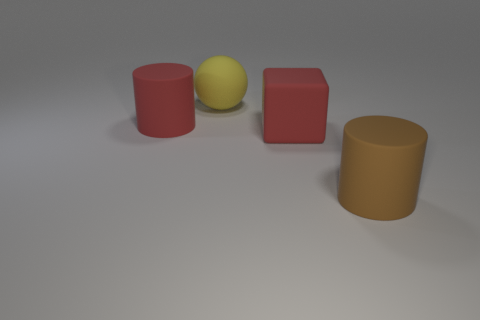There is a red block that is made of the same material as the large brown cylinder; what size is it?
Offer a terse response. Large. Is the shape of the thing that is on the left side of the sphere the same as the large red rubber object that is to the right of the yellow matte sphere?
Provide a succinct answer. No. What is the color of the big cube that is made of the same material as the ball?
Your answer should be compact. Red. What is the shape of the large thing that is both in front of the yellow matte object and behind the large rubber block?
Keep it short and to the point. Cylinder. Are there any tiny gray spheres made of the same material as the brown object?
Your answer should be very brief. No. What is the material of the large thing that is the same color as the large matte block?
Your answer should be very brief. Rubber. Is the material of the big red object in front of the big red cylinder the same as the big cylinder on the right side of the sphere?
Offer a very short reply. Yes. Are there more small blue cubes than yellow rubber things?
Offer a terse response. No. There is a big cylinder left of the large thing right of the big red matte object to the right of the big yellow matte ball; what color is it?
Keep it short and to the point. Red. Do the matte object that is in front of the red cube and the cylinder that is on the left side of the red block have the same color?
Offer a terse response. No. 